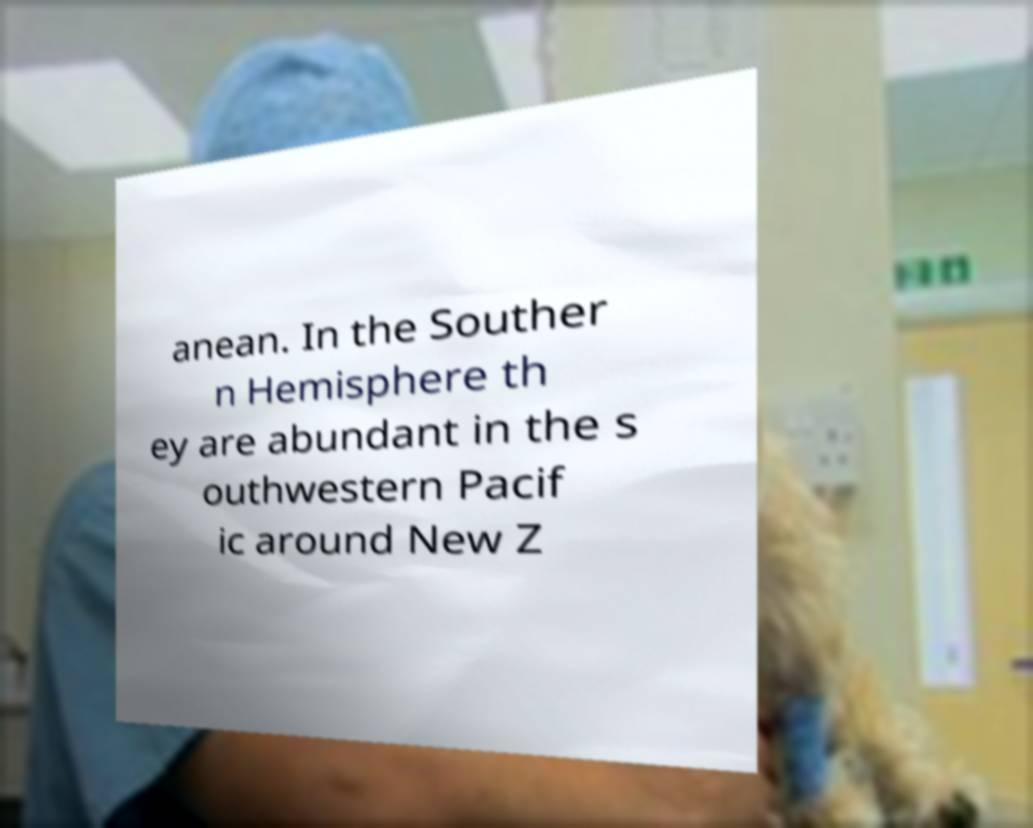Please identify and transcribe the text found in this image. anean. In the Souther n Hemisphere th ey are abundant in the s outhwestern Pacif ic around New Z 